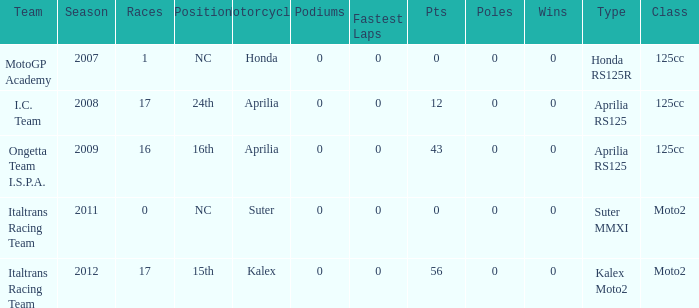What's the name of the team who had a Honda motorcycle? MotoGP Academy. 